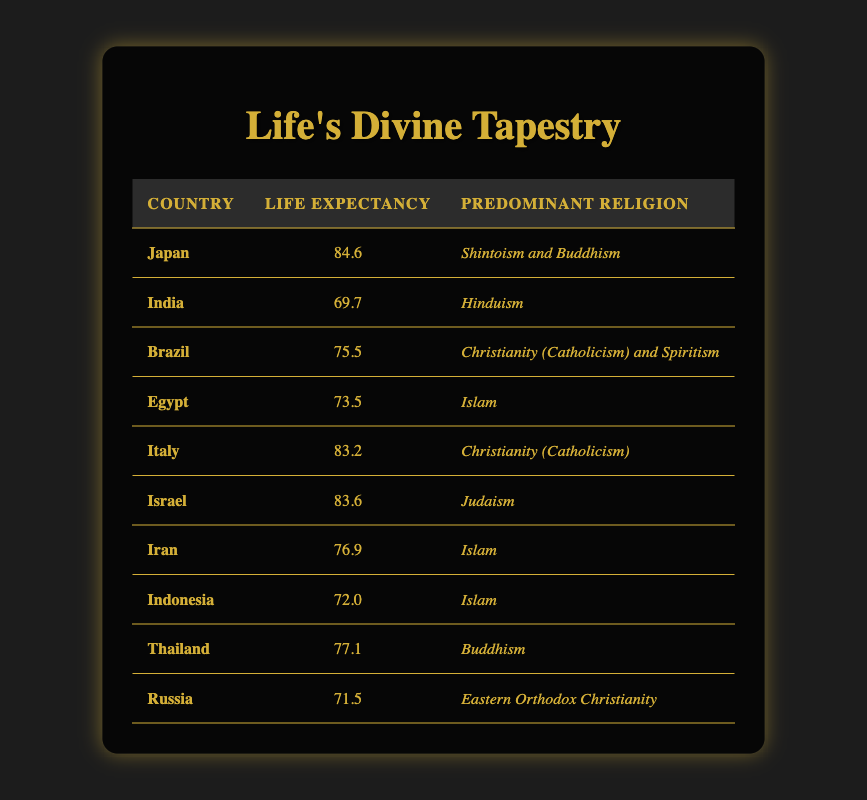What is the life expectancy of Japan? The table shows that Japan has a life expectancy of 84.6 years.
Answer: 84.6 Which country has the lowest life expectancy in the table? By examining the life expectancy figures, India has the lowest at 69.7 years.
Answer: India Is the predominant religion in Brazil Christianity? The table indicates that Brazil's predominant religion is Christianity (Catholicism) and Spiritism, so the statement is true.
Answer: Yes What is the average life expectancy of countries with Islam as their predominant religion? The countries with Islam as the predominant religion are Egypt (73.5), Iran (76.9), and Indonesia (72.0). Their total life expectancy is 73.5 + 76.9 + 72.0 = 222.4. The average is 222.4 divided by 3, which is 74.13.
Answer: 74.13 True or False: Thailand has a higher life expectancy than Italy. The table shows Thailand has a life expectancy of 77.1, while Italy has 83.2, therefore the statement is false.
Answer: False What is the life expectancy difference between Israel and Iran? Israel's life expectancy is 83.6, and Iran's is 76.9. The difference is 83.6 - 76.9 = 6.7 years.
Answer: 6.7 Among the countries listed, which has a life expectancy just above 75 years? The countries with a life expectancy just above 75 years are Brazil (75.5) and Iran (76.9). Both meet this criterion.
Answer: Brazil and Iran Are there any countries with Buddhism as a predominant religion that have a life expectancy above 80 years? The only country listed with Buddhism as the predominant religion is Thailand, which has a life expectancy of 77.1, therefore it does not meet the criterion.
Answer: No Which two countries have the highest and lowest life expectancy difference in the table? Japan (84.6) has the highest, and India (69.7) has the lowest. The difference is 84.6 - 69.7 = 14.9 years. Thus, Japan and India have the highest and lowest life expectancy difference.
Answer: Japan and India 